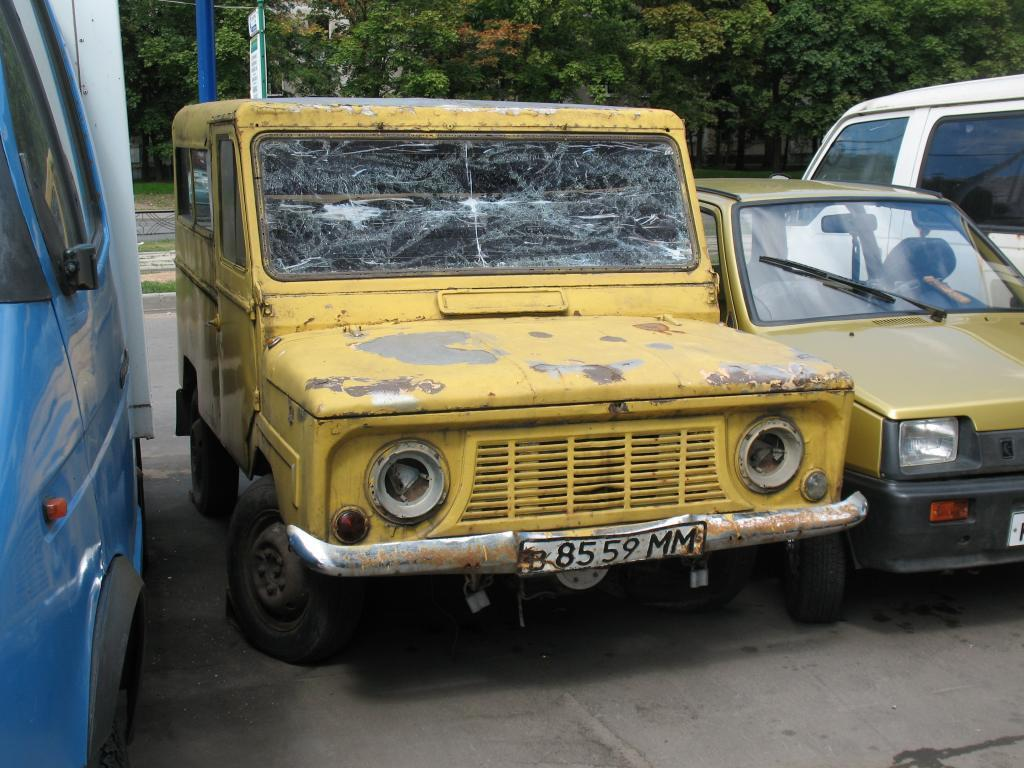What can be seen on the road in the image? There are vehicles on the road in the image. What is present in the background of the image? There is a board, a pole, trees, and grass in the background of the image. Can you describe the pole in the background? The pole in the background is a vertical structure, but its specific purpose or design cannot be determined from the image. What type of vegetation is visible in the background? Trees and grass are visible in the background of the image. What is the price of the dinner in the image? There is no reference to a price, dinner, or any financial transaction in the image. 